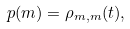<formula> <loc_0><loc_0><loc_500><loc_500>p ( m ) = \rho _ { m , m } ( t ) ,</formula> 